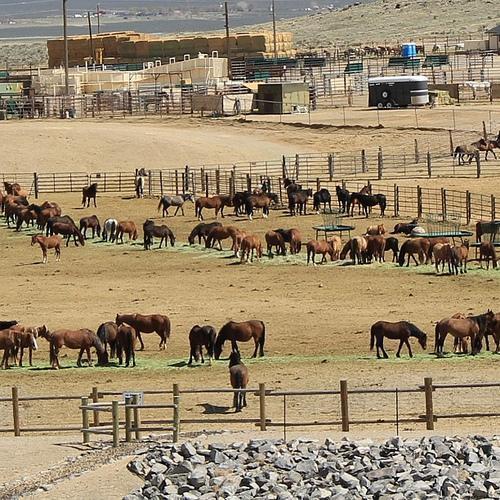How many horses are drinking water?
Give a very brief answer. 0. 